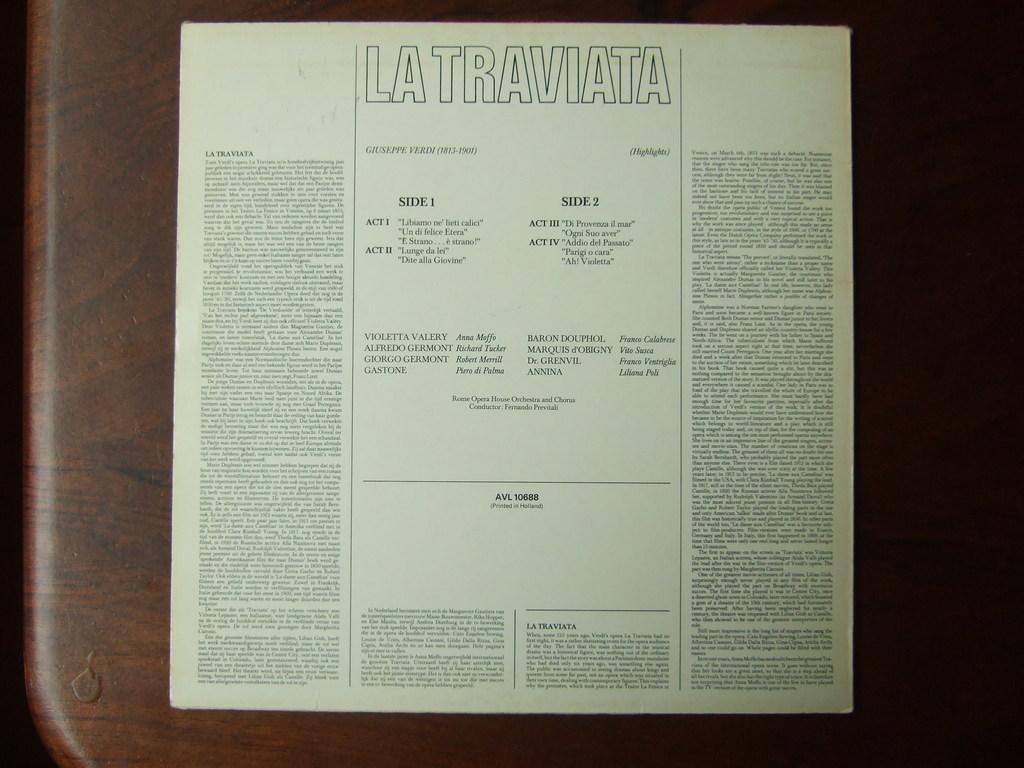<image>
Describe the image concisely. An insert from a record album of La Traviata with possible lyrics in very small print. 